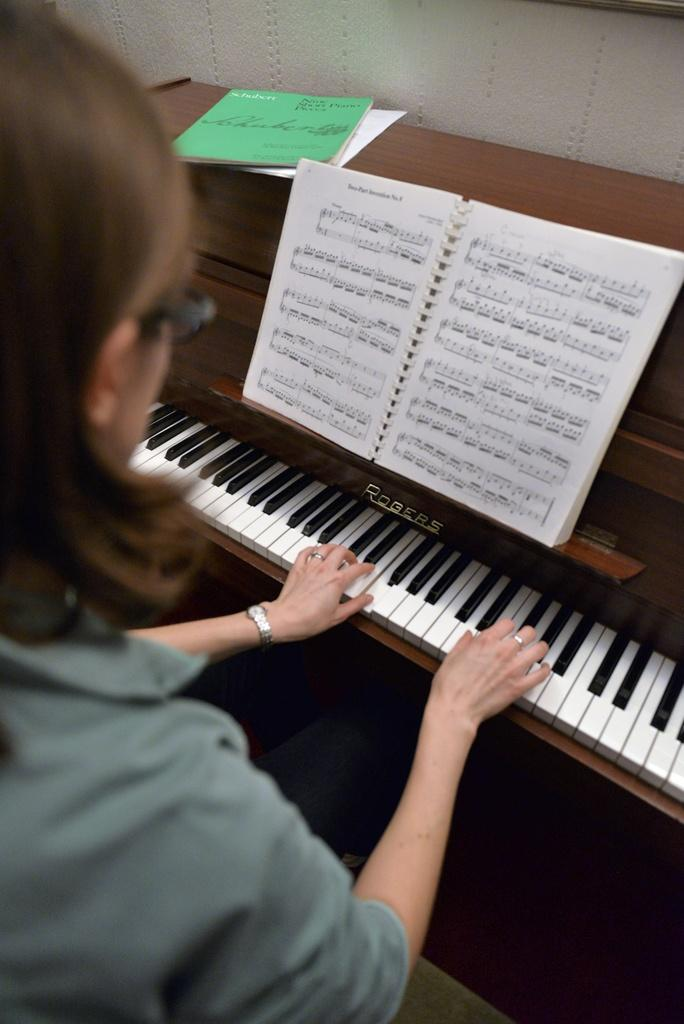What is the woman in the image doing? The woman is playing a keyboard. What object is placed on the keyboard? There is a book placed on the keyboard. How does the doctor increase the volume of the throat in the image? There is no doctor or throat present in the image; it features a woman playing a keyboard with a book on it. 